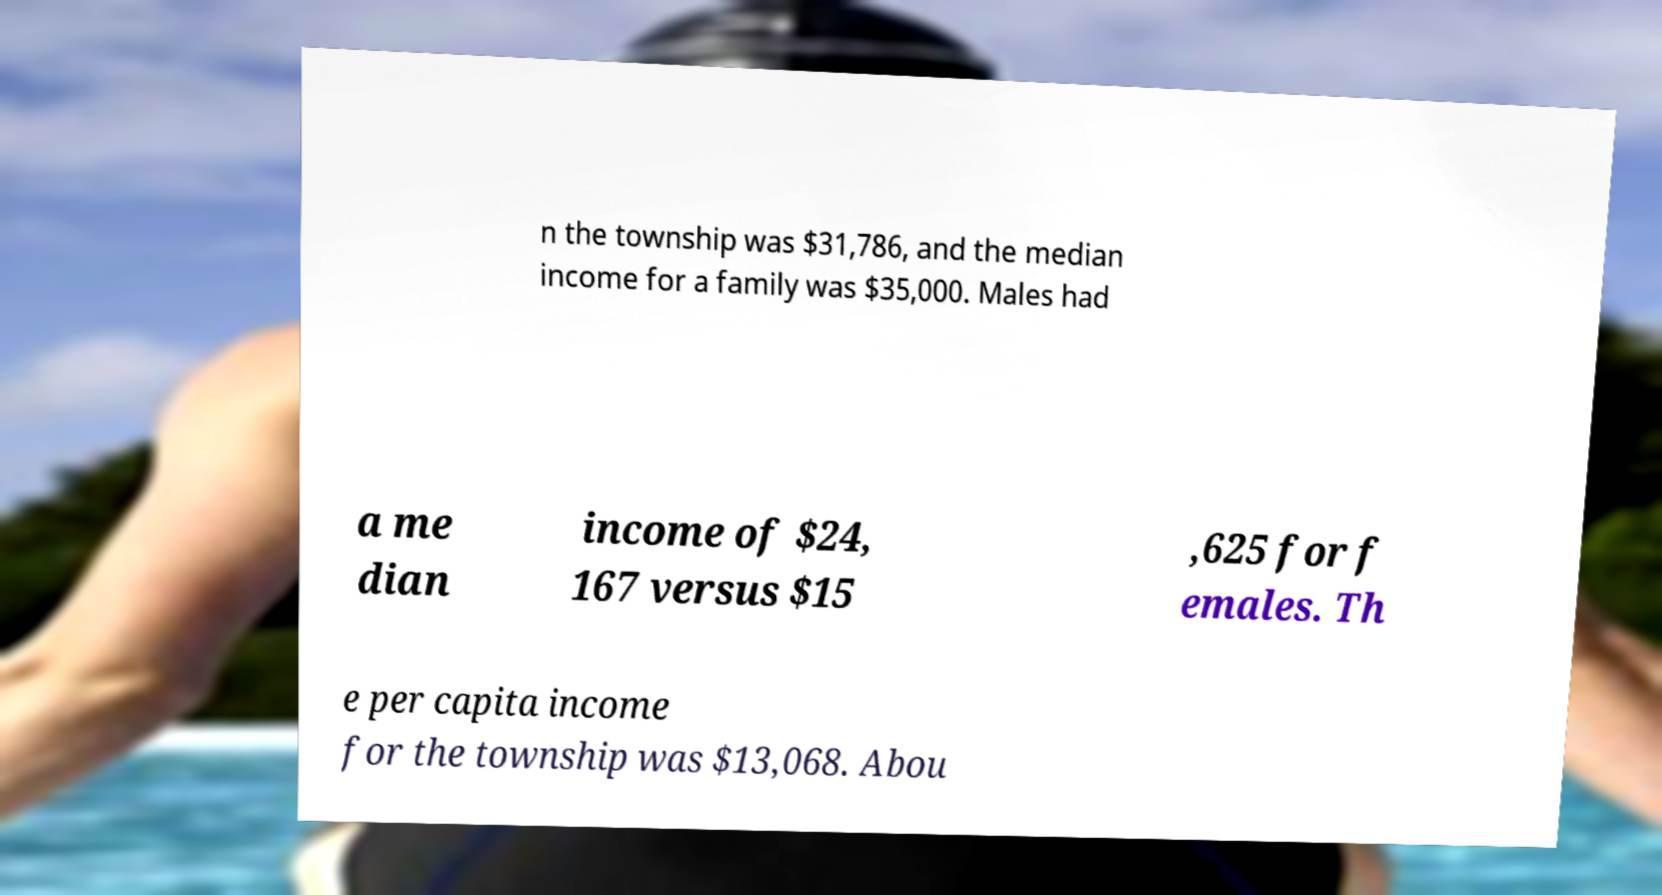Could you assist in decoding the text presented in this image and type it out clearly? n the township was $31,786, and the median income for a family was $35,000. Males had a me dian income of $24, 167 versus $15 ,625 for f emales. Th e per capita income for the township was $13,068. Abou 